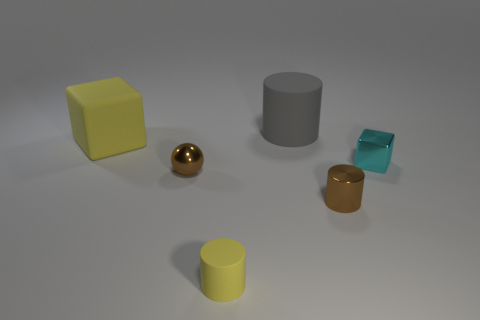Subtract all yellow cylinders. How many cylinders are left? 2 Add 2 metal cylinders. How many objects exist? 8 Subtract all yellow cylinders. How many cylinders are left? 2 Subtract all balls. How many objects are left? 5 Subtract 0 red cubes. How many objects are left? 6 Subtract 1 cylinders. How many cylinders are left? 2 Subtract all purple spheres. Subtract all blue cylinders. How many spheres are left? 1 Subtract all yellow cubes. Subtract all tiny brown metallic cylinders. How many objects are left? 4 Add 6 brown metallic cylinders. How many brown metallic cylinders are left? 7 Add 4 matte blocks. How many matte blocks exist? 5 